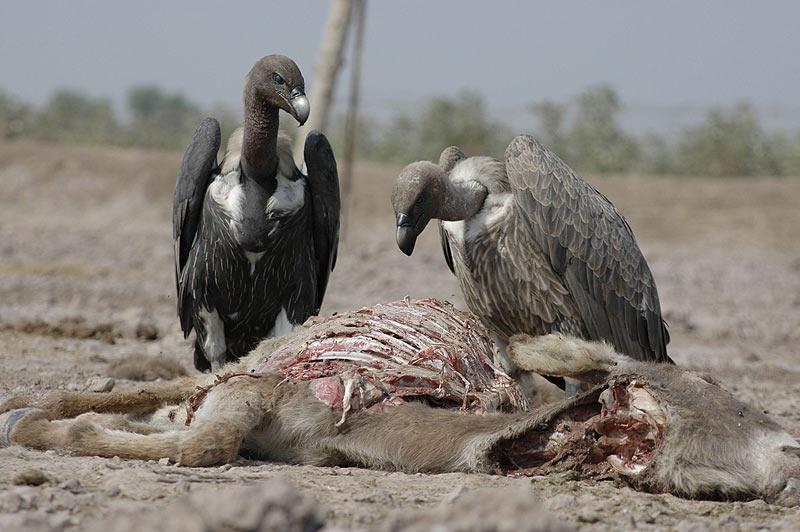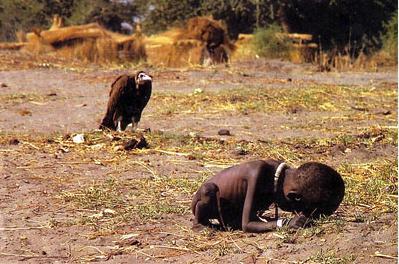The first image is the image on the left, the second image is the image on the right. Analyze the images presented: Is the assertion "Some of the birds are eating something that is on the ground." valid? Answer yes or no. Yes. The first image is the image on the left, the second image is the image on the right. Assess this claim about the two images: "There is exactly one bird with its wings folded in the image on the right". Correct or not? Answer yes or no. Yes. 